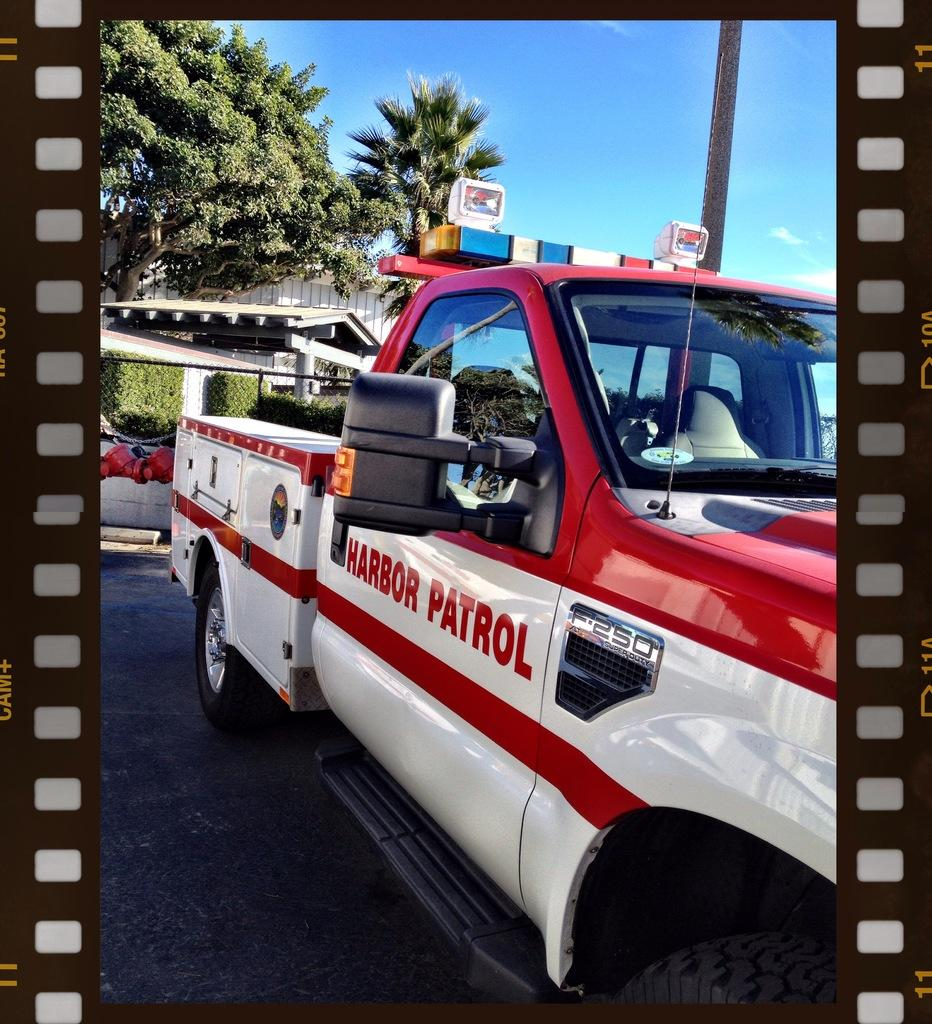What is the main subject in the middle of the image? There is a vehicle in the middle of the image. What can be seen in the background of the image? There are trees, tents, plants, a wall, a road, and poles in the background of the image. What part of the natural environment is visible in the image? The sky is visible in the background of the image, and there are clouds in the sky. Who is the creator of the engine in the image? There is no engine present in the image, so it is not possible to determine who the creator might be. 